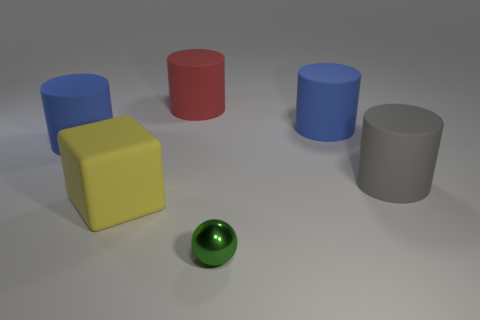Is there any other thing that has the same size as the green metal ball?
Provide a short and direct response. No. What color is the matte thing that is to the left of the big yellow object?
Give a very brief answer. Blue. Is the number of rubber blocks on the right side of the small green sphere the same as the number of small green spheres that are in front of the large matte block?
Your answer should be compact. No. The small ball that is in front of the blue matte cylinder on the right side of the big yellow block is made of what material?
Ensure brevity in your answer.  Metal. What number of objects are either blue things or cylinders in front of the red matte object?
Provide a succinct answer. 3. Is the number of blue things that are on the left side of the block greater than the number of tiny brown matte cubes?
Make the answer very short. Yes. What is the size of the thing that is both on the left side of the large gray cylinder and right of the small shiny sphere?
Provide a short and direct response. Large. There is a gray object that is the same shape as the large red object; what is its material?
Your answer should be very brief. Rubber. Is the size of the yellow block that is on the left side of the green sphere the same as the green thing?
Your answer should be compact. No. There is a object that is both in front of the big gray object and behind the metallic object; what is its color?
Provide a succinct answer. Yellow. 